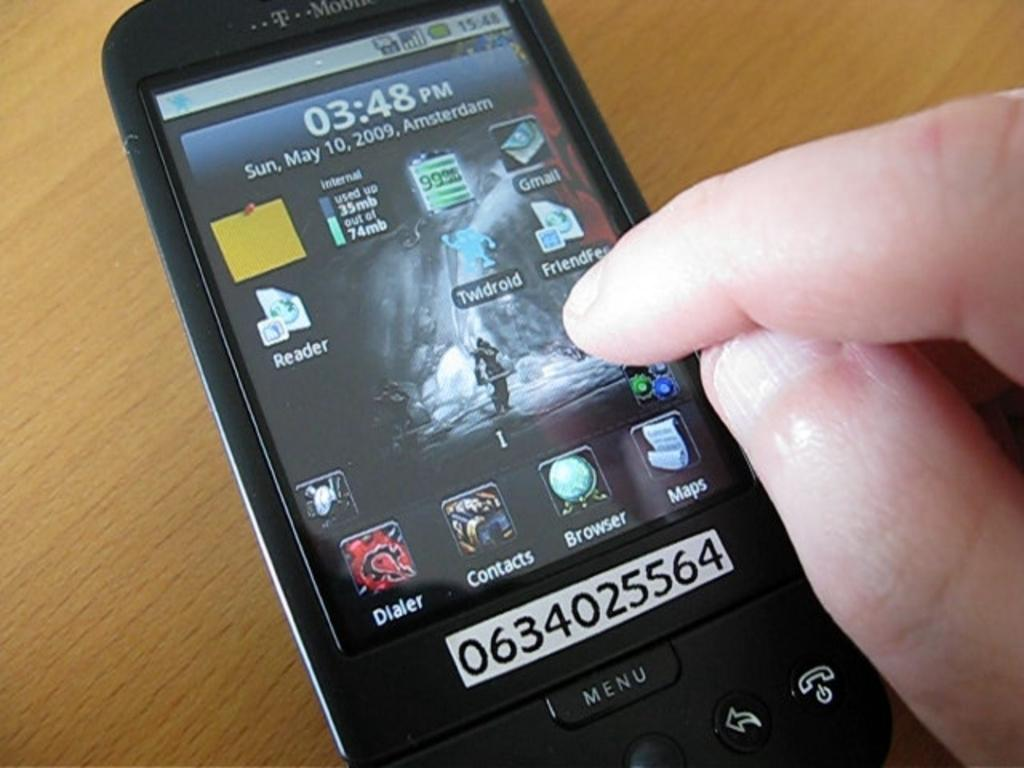Provide a one-sentence caption for the provided image. As a cell phone sits on a table, a person goes to select the Twldroid app. 